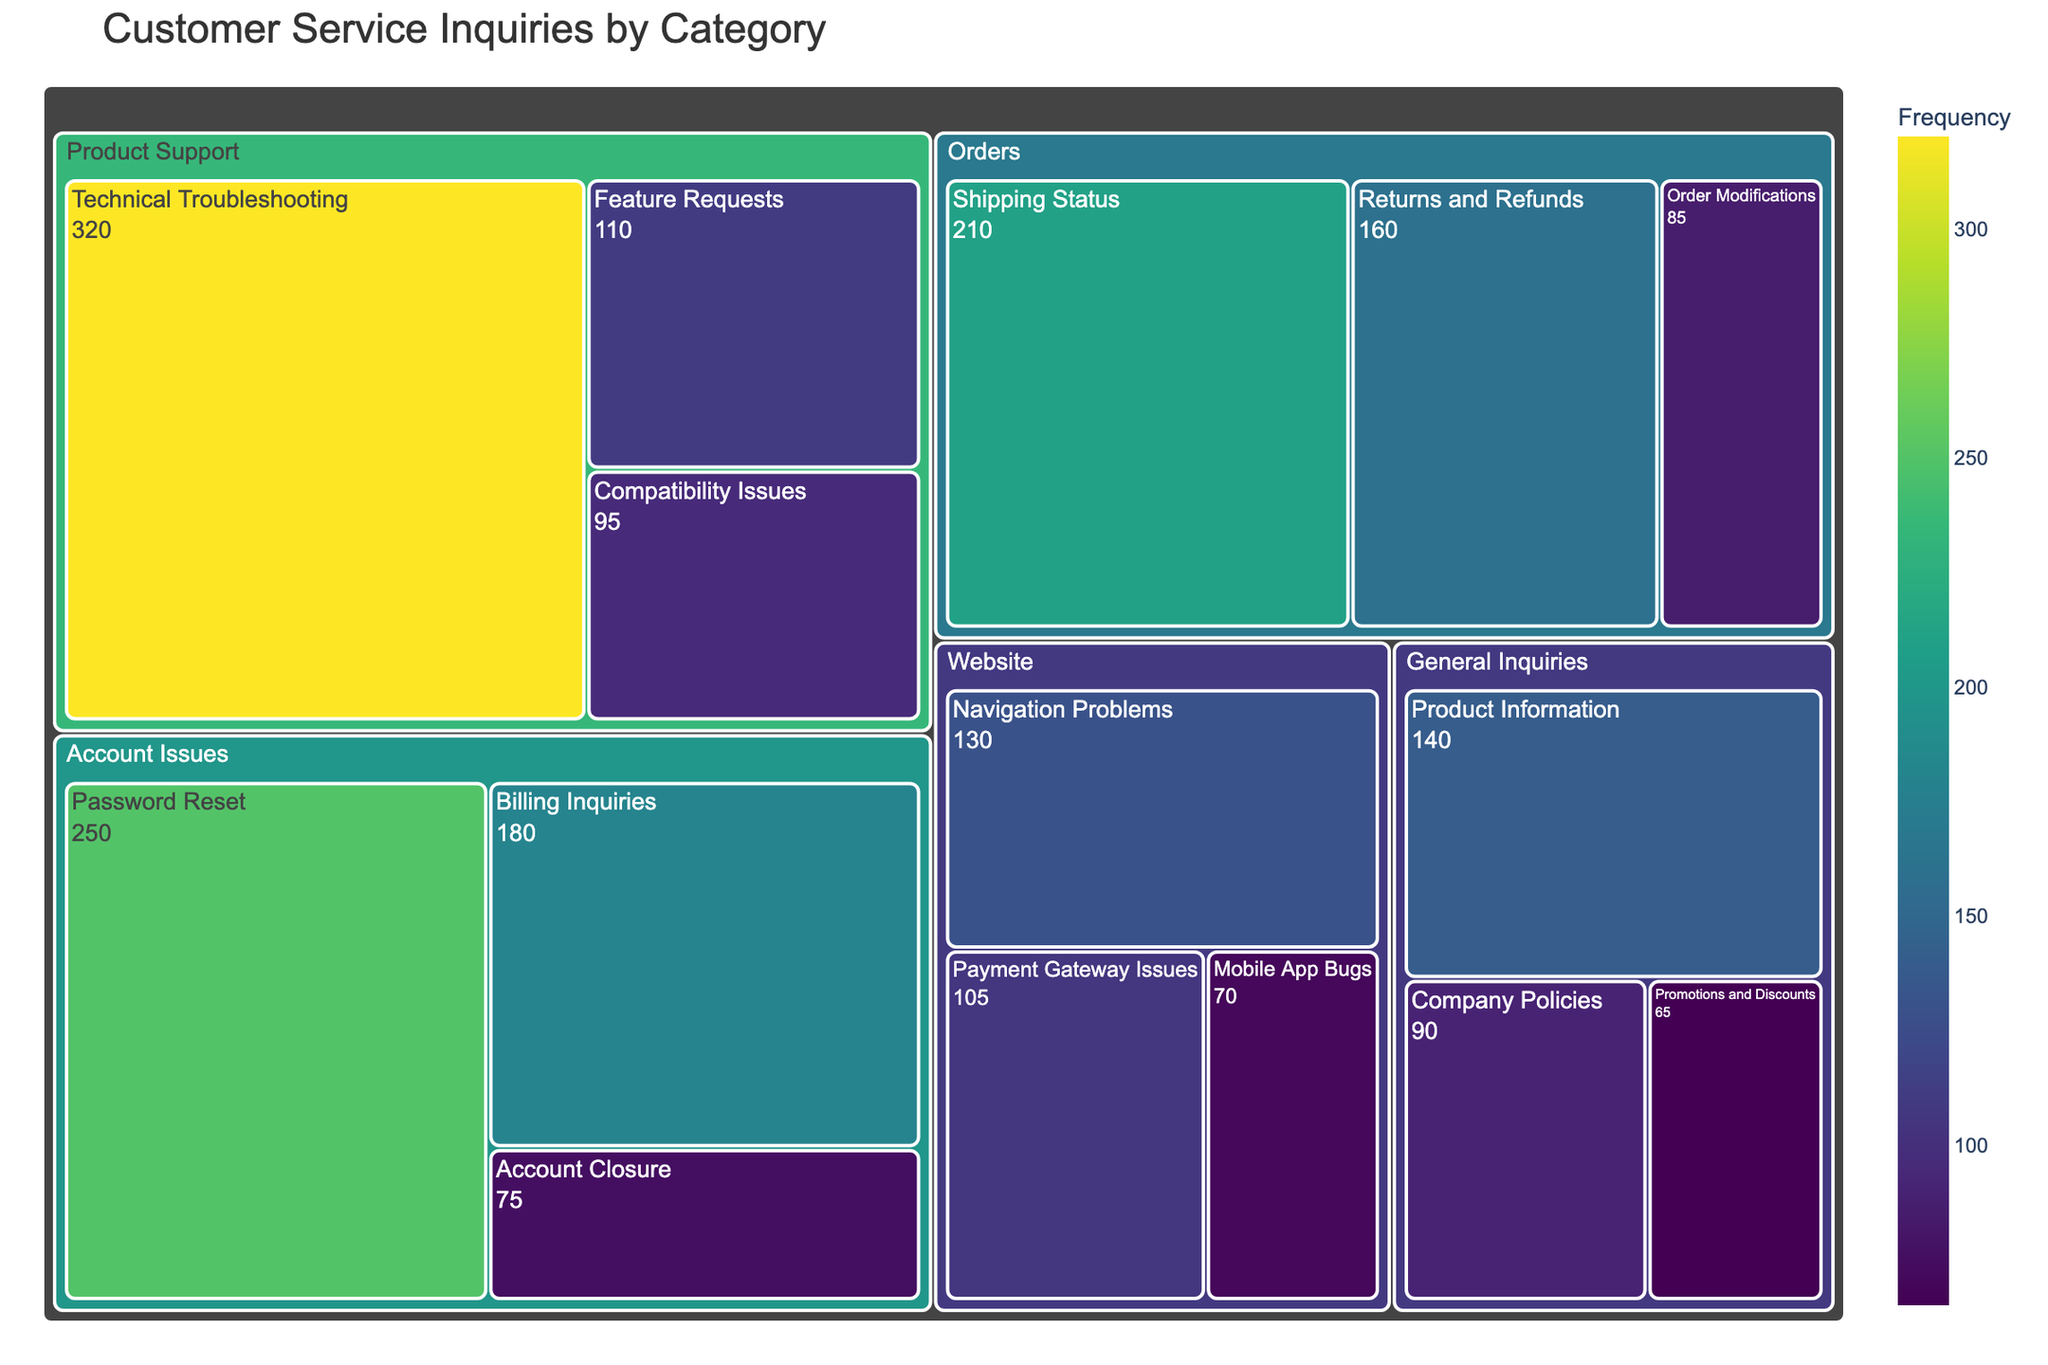What is the most frequently mentioned subcategory? To find the most frequently mentioned subcategory, locate the subcategory box with the highest value. From the figure, "Technical Troubleshooting" has the highest value of 320, which is the most frequently mentioned subcategory.
Answer: Technical Troubleshooting Which category has the least number of inquiries? To determine the category with the least inquiries, sum the values of each subcategory within each category, then compare these sums. The sum for "General Inquiries" (140 + 90 + 65 = 295) is the smallest compared to other categories.
Answer: General Inquiries How many inquiries are there about "Orders"? Sum the values of all subcategories under "Orders" (210 for Shipping Status, 160 for Returns and Refunds, 85 for Order Modifications). The total is 210 + 160 + 85 = 455.
Answer: 455 Which is higher, inquiries about "Mobile App Bugs" or "Order Modifications"? Compare the values of the two subcategories. "Mobile App Bugs" has a value of 70, and "Order Modifications" has a value of 85. Since 85 is greater than 70, inquiries about "Order Modifications" are higher.
Answer: Order Modifications What percentage of the total "Product Support" category inquiries are for "Feature Requests"? First, find the total number of inquiries for "Product Support" by summing the subcategory values (320 + 110 + 95 = 525). Then, calculate the percentage of "Feature Requests" (110) within this total: (110 / 525) * 100 ≈ 20.95%.
Answer: 20.95% How many more inquiries are there about "Technical Troubleshooting" than "Shipping Status"? Find the difference between the values of "Technical Troubleshooting" (320) and "Shipping Status" (210). The difference is 320 - 210 = 110.
Answer: 110 Which category has a higher total of inquiries, "Website" or "General Inquiries"? Sum the values for each category. For "Website", the sum is 130 + 105 + 70 = 305. For "General Inquiries", the sum is 140 + 90 + 65 = 295. "Website" has a higher total (305 vs. 295).
Answer: Website What is the combined total of inquiries for "Password Reset" and "Billing Inquiries"? Add the values for "Password Reset" (250) and "Billing Inquiries" (180). The combined total is 250 + 180 = 430.
Answer: 430 Is "Company Policies" more or less frequent than "Feature Requests"? Compare the values of "Company Policies" (90) and "Feature Requests" (110). Since 90 is less than 110, "Company Policies" is less frequent.
Answer: less What is the total number of customer service inquiries represented in the figure? Sum all subcategory values: 250 + 180 + 75 + 320 + 110 + 95 + 210 + 160 + 85 + 130 + 105 + 70 + 140 + 90 + 65 = 2085.
Answer: 2085 